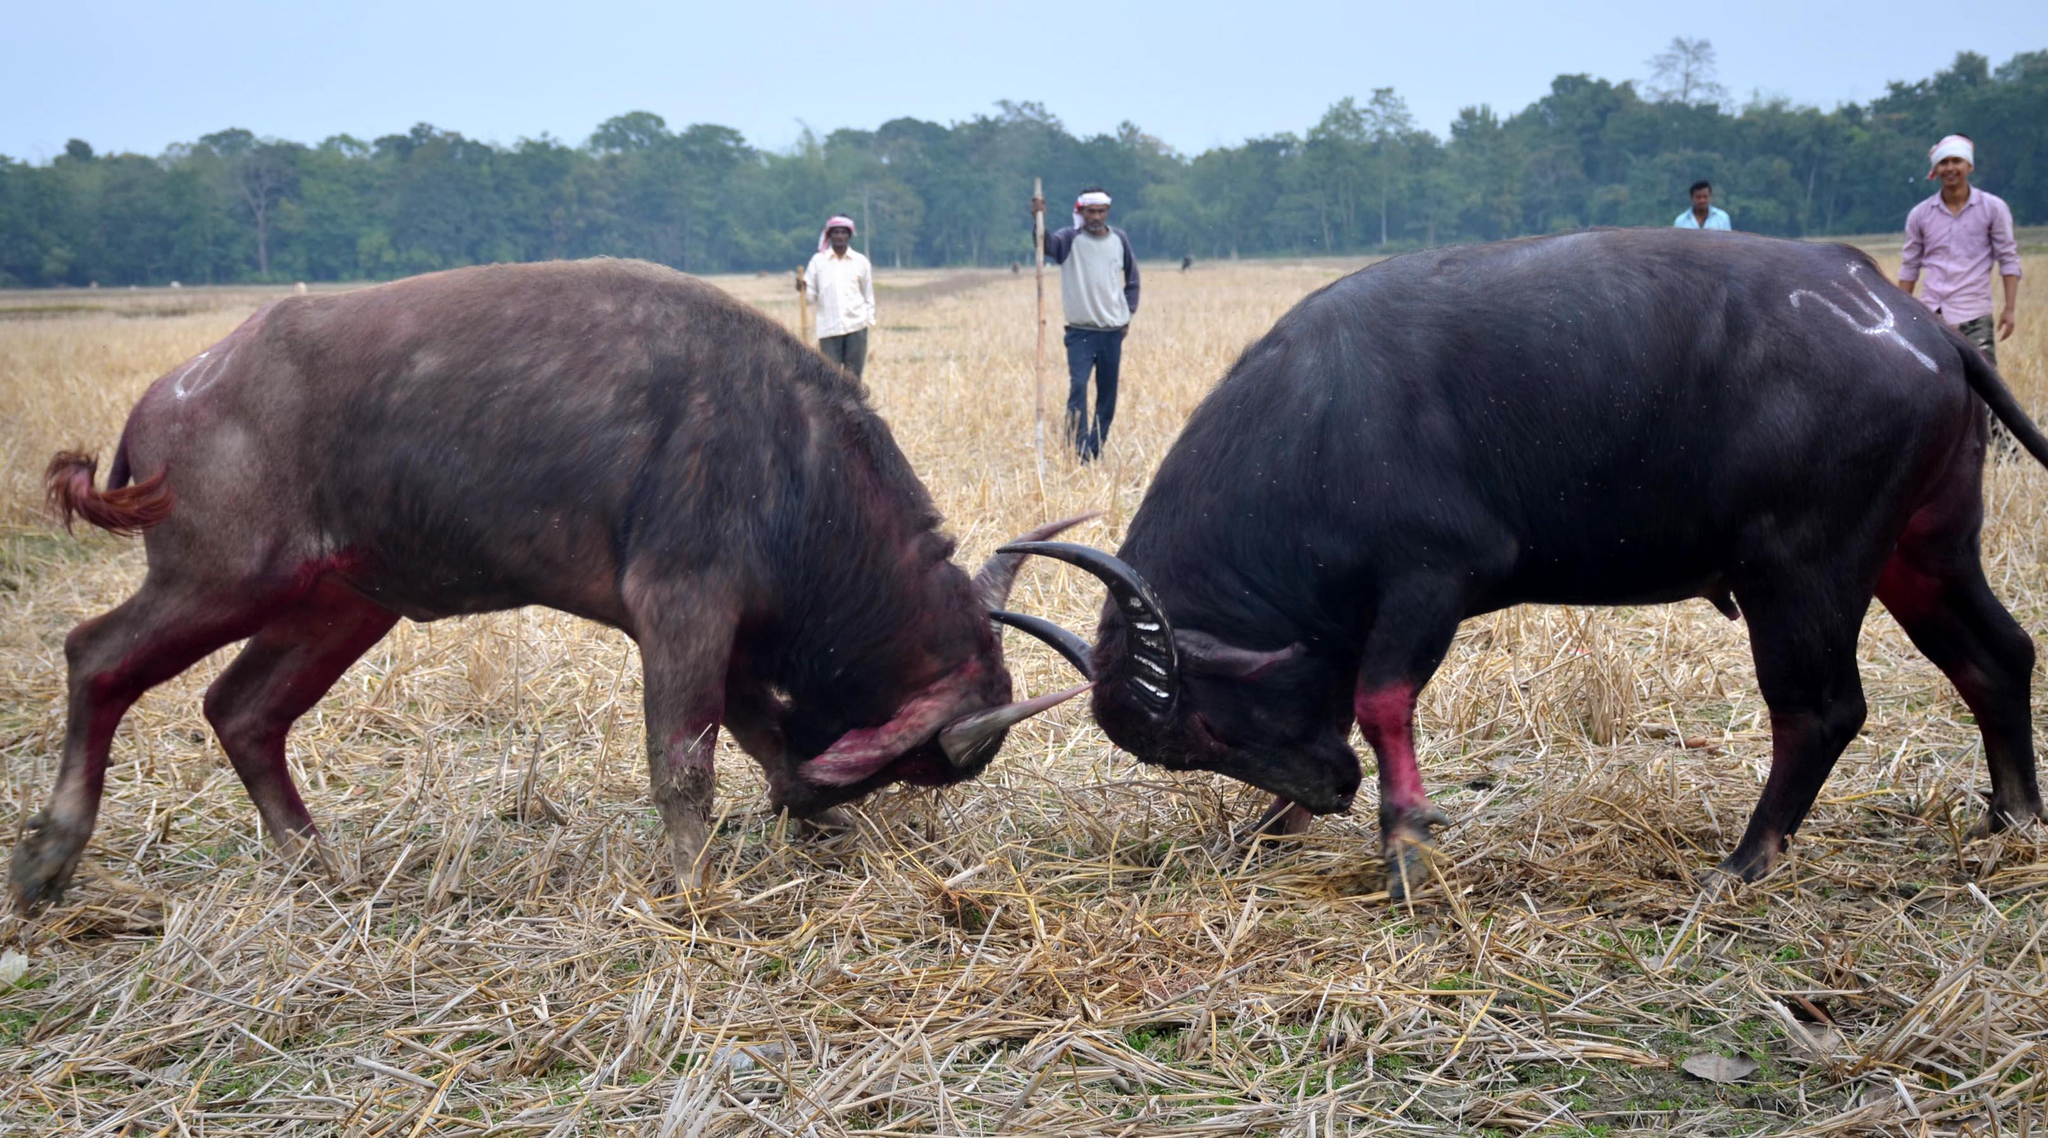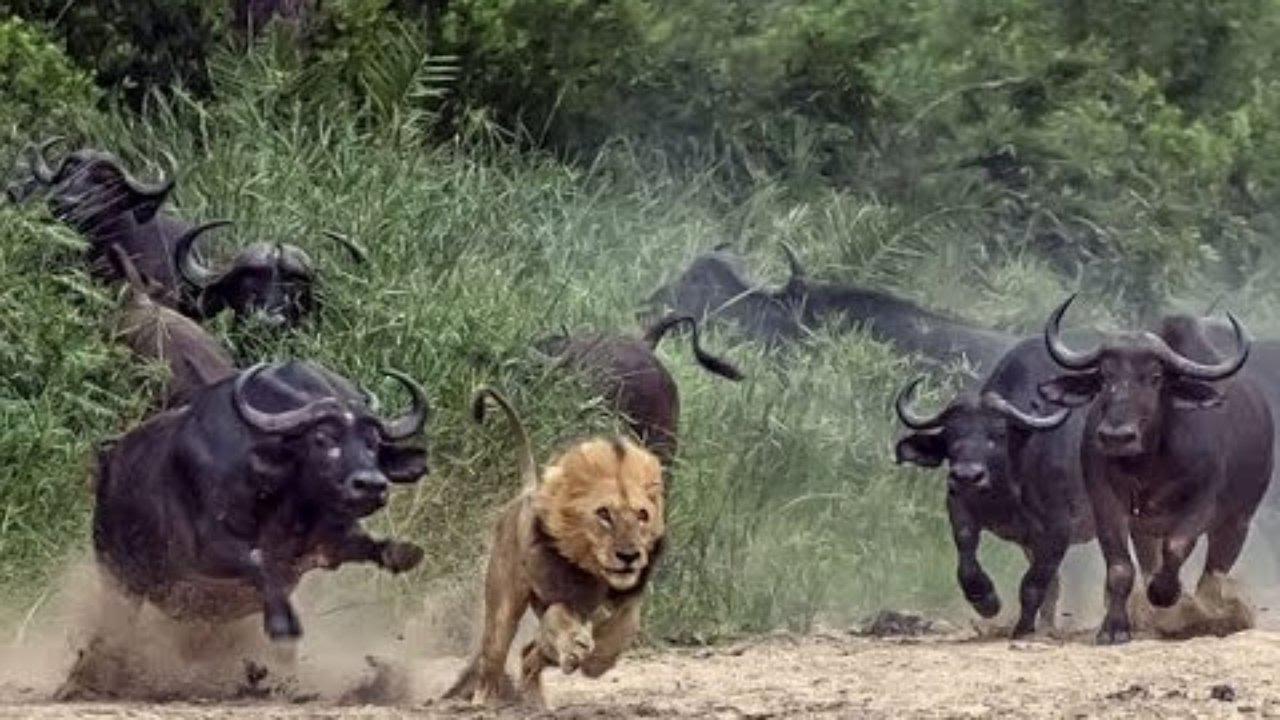The first image is the image on the left, the second image is the image on the right. For the images shown, is this caption "In one of the images, the wildebeest are chasing the lion." true? Answer yes or no. Yes. 